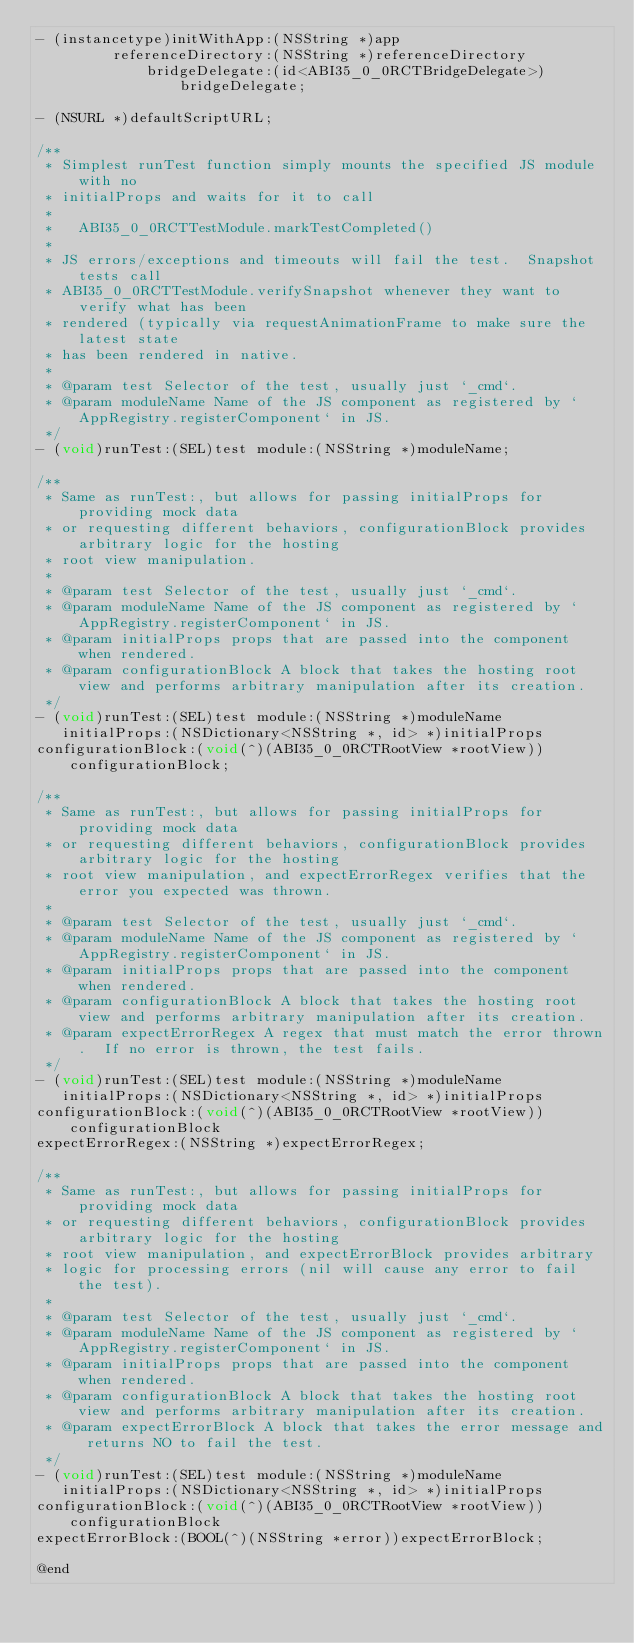<code> <loc_0><loc_0><loc_500><loc_500><_C_>- (instancetype)initWithApp:(NSString *)app
         referenceDirectory:(NSString *)referenceDirectory
             bridgeDelegate:(id<ABI35_0_0RCTBridgeDelegate>)bridgeDelegate;

- (NSURL *)defaultScriptURL;

/**
 * Simplest runTest function simply mounts the specified JS module with no
 * initialProps and waits for it to call
 *
 *   ABI35_0_0RCTTestModule.markTestCompleted()
 *
 * JS errors/exceptions and timeouts will fail the test.  Snapshot tests call
 * ABI35_0_0RCTTestModule.verifySnapshot whenever they want to verify what has been
 * rendered (typically via requestAnimationFrame to make sure the latest state
 * has been rendered in native.
 *
 * @param test Selector of the test, usually just `_cmd`.
 * @param moduleName Name of the JS component as registered by `AppRegistry.registerComponent` in JS.
 */
- (void)runTest:(SEL)test module:(NSString *)moduleName;

/**
 * Same as runTest:, but allows for passing initialProps for providing mock data
 * or requesting different behaviors, configurationBlock provides arbitrary logic for the hosting
 * root view manipulation.
 *
 * @param test Selector of the test, usually just `_cmd`.
 * @param moduleName Name of the JS component as registered by `AppRegistry.registerComponent` in JS.
 * @param initialProps props that are passed into the component when rendered.
 * @param configurationBlock A block that takes the hosting root view and performs arbitrary manipulation after its creation.
 */
- (void)runTest:(SEL)test module:(NSString *)moduleName
   initialProps:(NSDictionary<NSString *, id> *)initialProps
configurationBlock:(void(^)(ABI35_0_0RCTRootView *rootView))configurationBlock;

/**
 * Same as runTest:, but allows for passing initialProps for providing mock data
 * or requesting different behaviors, configurationBlock provides arbitrary logic for the hosting
 * root view manipulation, and expectErrorRegex verifies that the error you expected was thrown.
 *
 * @param test Selector of the test, usually just `_cmd`.
 * @param moduleName Name of the JS component as registered by `AppRegistry.registerComponent` in JS.
 * @param initialProps props that are passed into the component when rendered.
 * @param configurationBlock A block that takes the hosting root view and performs arbitrary manipulation after its creation.
 * @param expectErrorRegex A regex that must match the error thrown.  If no error is thrown, the test fails.
 */
- (void)runTest:(SEL)test module:(NSString *)moduleName
   initialProps:(NSDictionary<NSString *, id> *)initialProps
configurationBlock:(void(^)(ABI35_0_0RCTRootView *rootView))configurationBlock
expectErrorRegex:(NSString *)expectErrorRegex;

/**
 * Same as runTest:, but allows for passing initialProps for providing mock data
 * or requesting different behaviors, configurationBlock provides arbitrary logic for the hosting
 * root view manipulation, and expectErrorBlock provides arbitrary
 * logic for processing errors (nil will cause any error to fail the test).
 *
 * @param test Selector of the test, usually just `_cmd`.
 * @param moduleName Name of the JS component as registered by `AppRegistry.registerComponent` in JS.
 * @param initialProps props that are passed into the component when rendered.
 * @param configurationBlock A block that takes the hosting root view and performs arbitrary manipulation after its creation.
 * @param expectErrorBlock A block that takes the error message and returns NO to fail the test.
 */
- (void)runTest:(SEL)test module:(NSString *)moduleName
   initialProps:(NSDictionary<NSString *, id> *)initialProps
configurationBlock:(void(^)(ABI35_0_0RCTRootView *rootView))configurationBlock
expectErrorBlock:(BOOL(^)(NSString *error))expectErrorBlock;

@end
</code> 